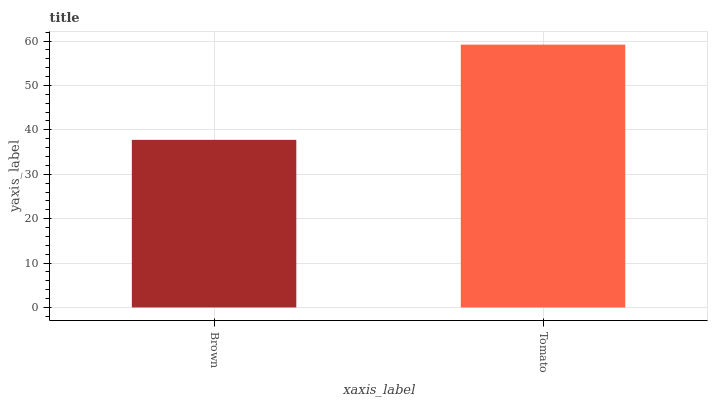Is Brown the minimum?
Answer yes or no. Yes. Is Tomato the maximum?
Answer yes or no. Yes. Is Tomato the minimum?
Answer yes or no. No. Is Tomato greater than Brown?
Answer yes or no. Yes. Is Brown less than Tomato?
Answer yes or no. Yes. Is Brown greater than Tomato?
Answer yes or no. No. Is Tomato less than Brown?
Answer yes or no. No. Is Tomato the high median?
Answer yes or no. Yes. Is Brown the low median?
Answer yes or no. Yes. Is Brown the high median?
Answer yes or no. No. Is Tomato the low median?
Answer yes or no. No. 